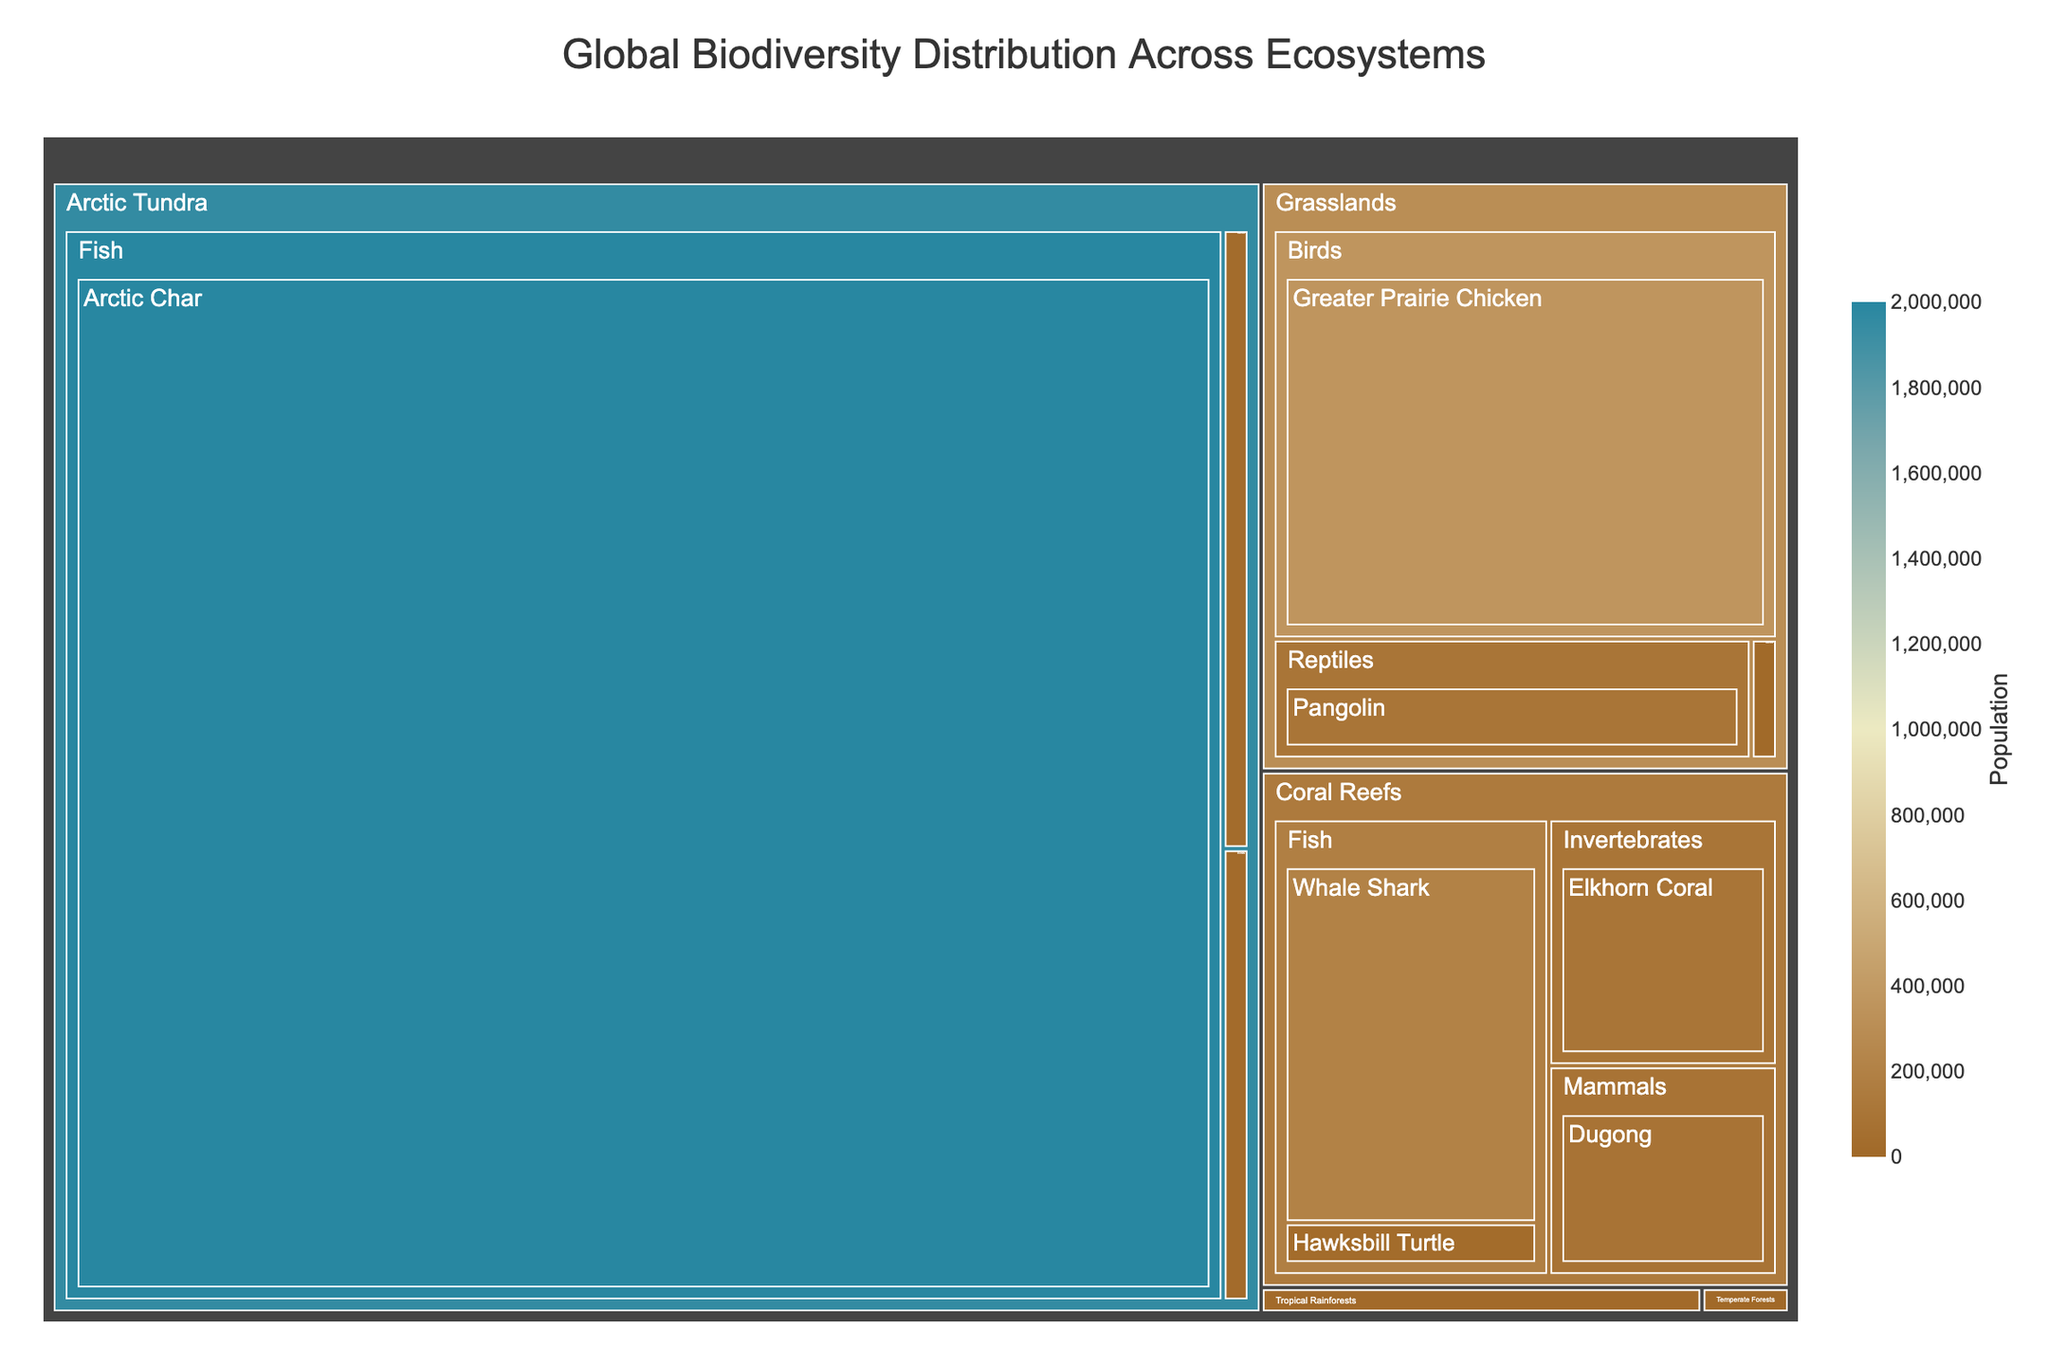What is the title of the treemap? The title is usually displayed at the top of the treemap, making it the easiest information to identify. It helps viewers quickly understand the subject of the visualization.
Answer: Global Biodiversity Distribution Across Ecosystems Which ecosystem has the species with the highest population? Look for the section in the treemap that occupies the largest area or has the highest value in the hover data. The size in a treemap often indicates the value of its underlying data, hence the biggest block represents the species with the highest population.
Answer: Arctic Tundra What is the population of the Polar Bear species? Locate the Arctic Tundra ecosystem, then identify the Polar Bear within the Mammals category. The population value should be readily visible via hover data or the size of the block.
Answer: 26000 Which ecosystem has the fewest number of endangered mammal species? We need to identify the number of Mammal species blocks for each ecosystem. The one with the least number of these blocks will have the fewest endangered mammal species.
Answer: Arctic Tundra How does the population of Whale Shark compare to that of the Arctic Char? Identify the Whale Shark within the Coral Reefs ecosystem and Arctic Char in the Arctic Tundra ecosystem, then compare their population values directly.
Answer: The population of Arctic Char is significantly higher than that of Whale Shark Which species has the lowest population in the Tropical Rainforests? Browse through species within the Tropical Rainforests and compare their populations. The smallest block or lowest population value indicates the species with the smallest population.
Answer: Amur Leopard Between the Golden Poison Frog and the Whale Shark, which has a larger population? Navigate to the Golden Poison Frog in Tropical Rainforests and the Whale Shark in Coral Reefs, then compare their population figures.
Answer: Whale Shark How does the population distribution of birds in the Arctic Tundra compare to those in the Temperate Forests? Locate the bird species under both ecosystems and note their population values. Compare the total or individual populations.
Answer: The Arctic Tundra has Ivory Gull with a population of 19000, while Temperate Forests has California Condor with a population of 463. The Arctic Tundra has a significantly higher population of birds 